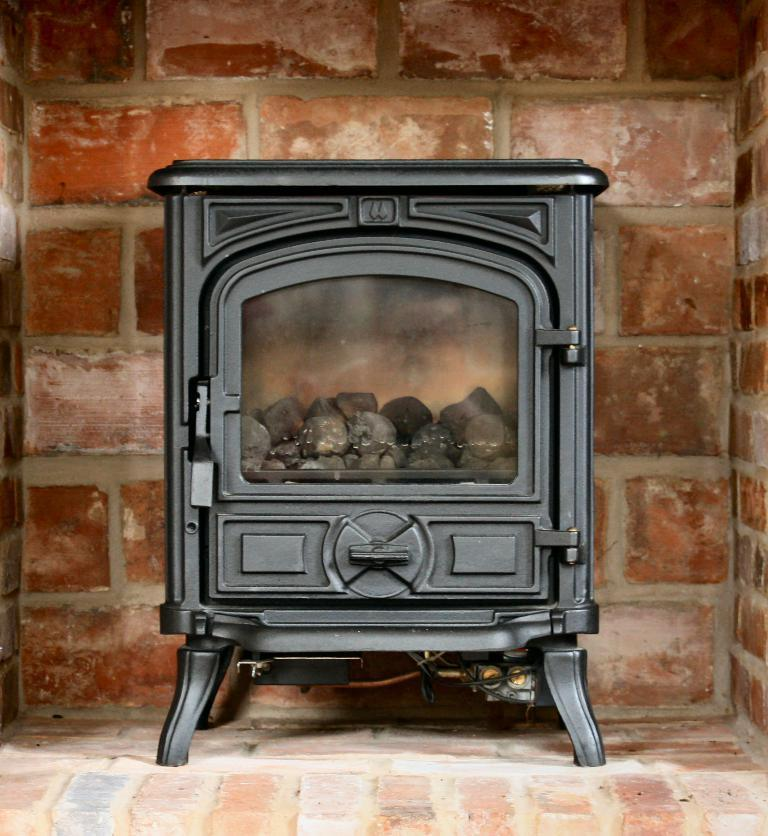What is the main feature in the image? There is a fireplace in the image. What can be seen in the background of the image? There is a brick wall in the background of the image. How many dolls are attempting to climb the fireplace in the image? There are no dolls present in the image, and therefore no such attempt can be observed. 